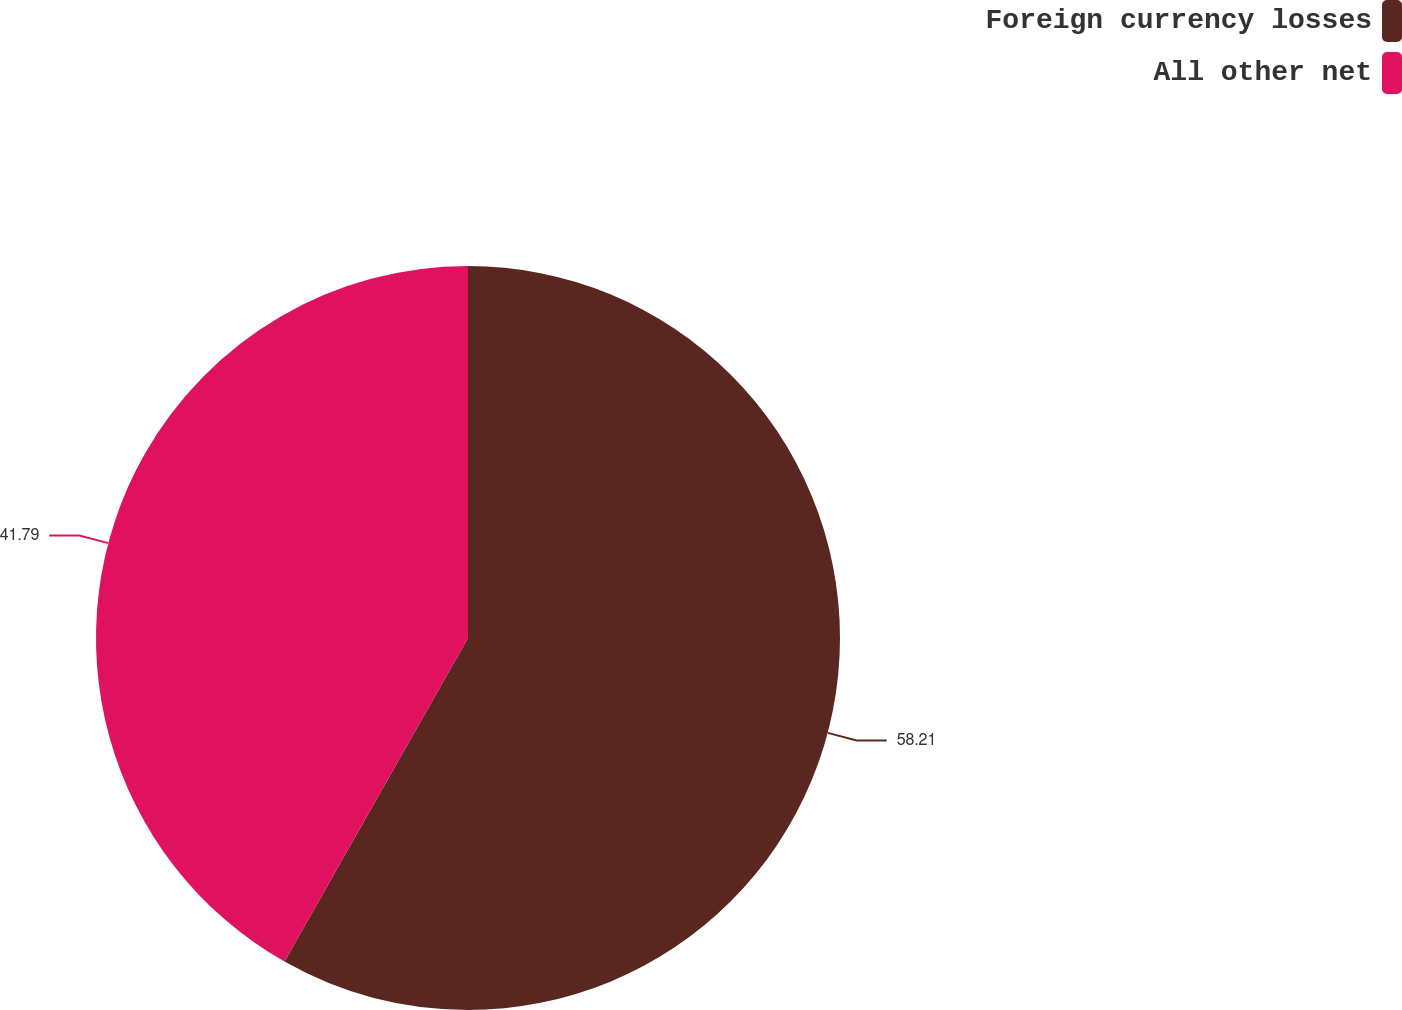Convert chart to OTSL. <chart><loc_0><loc_0><loc_500><loc_500><pie_chart><fcel>Foreign currency losses<fcel>All other net<nl><fcel>58.21%<fcel>41.79%<nl></chart> 